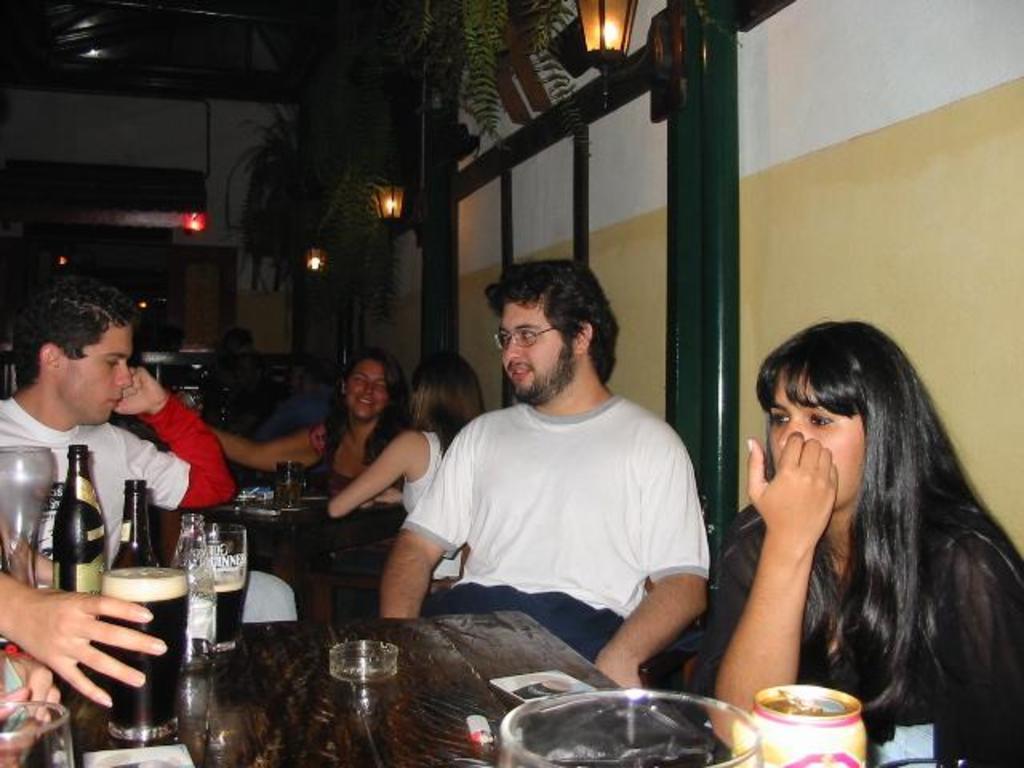Could you give a brief overview of what you see in this image? This picture shows a group of people seated and we see some glasses and beer bottles on the table. 